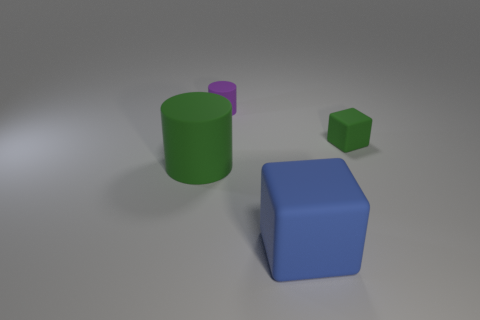What might be the relative sizes of these objects? The large blue cube appears to be the biggest object within the scene, followed by the green cylinder. The smallest object is the green cube. 